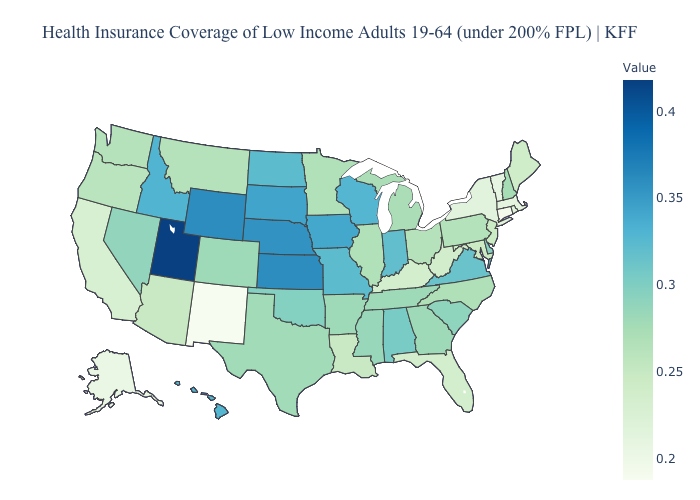Does Connecticut have the lowest value in the Northeast?
Give a very brief answer. Yes. Does Utah have the highest value in the USA?
Answer briefly. Yes. Which states hav the highest value in the Northeast?
Give a very brief answer. New Hampshire. Is the legend a continuous bar?
Answer briefly. Yes. 